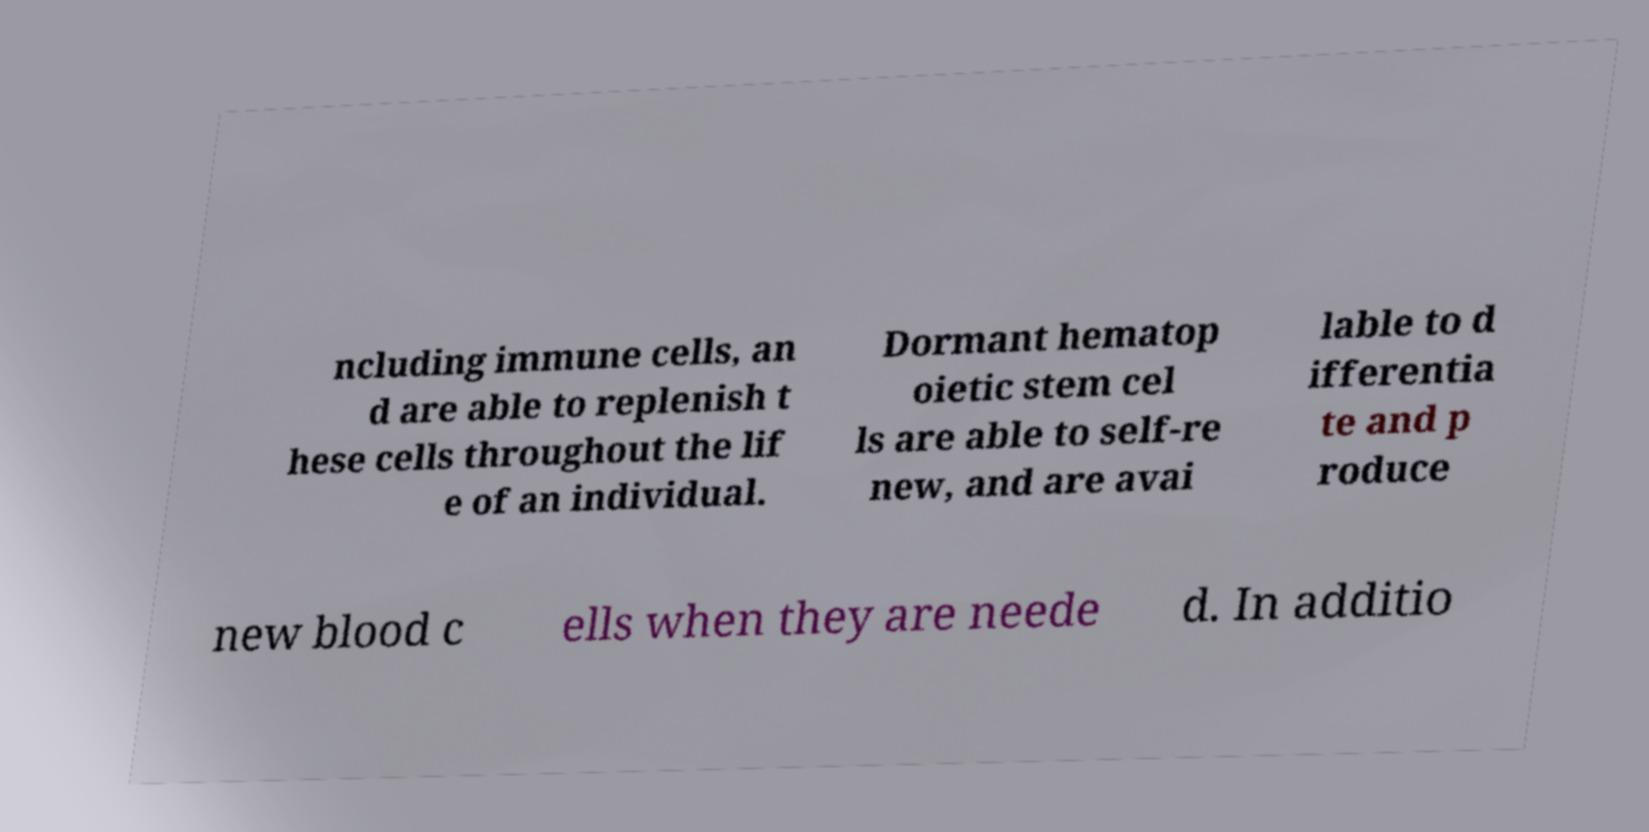What messages or text are displayed in this image? I need them in a readable, typed format. ncluding immune cells, an d are able to replenish t hese cells throughout the lif e of an individual. Dormant hematop oietic stem cel ls are able to self-re new, and are avai lable to d ifferentia te and p roduce new blood c ells when they are neede d. In additio 